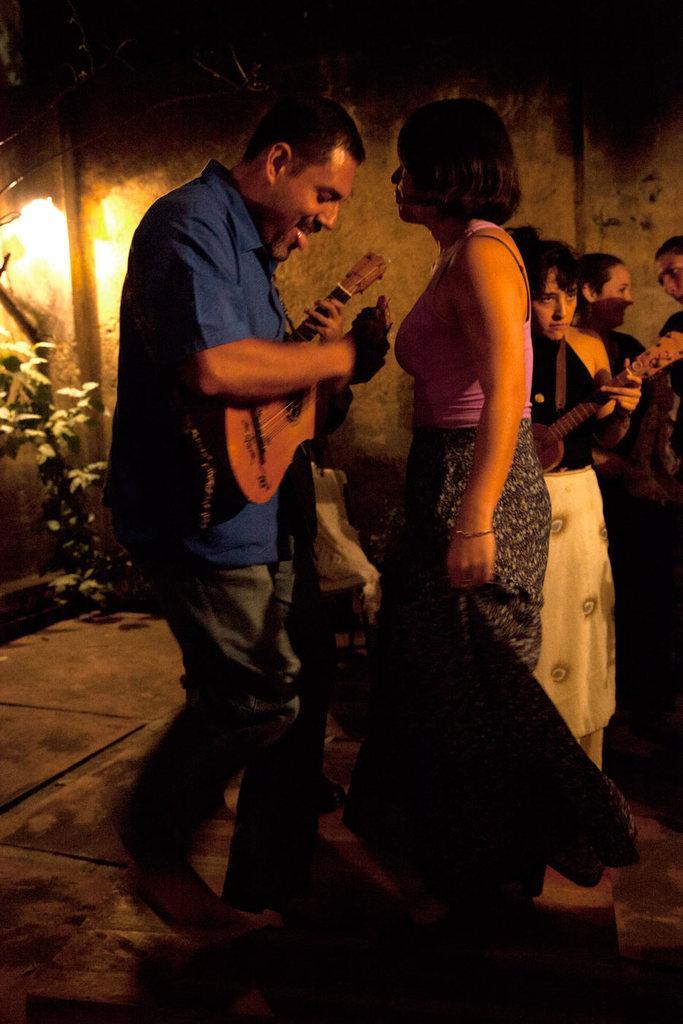How would you summarize this image in a sentence or two? In this image person wearing a blue shirt is holding a guitar. Before there is a woman is standing. At the right side there are few women. In which one woman wearing a black top and white bottom is holding a guitar. At the left side there is a plant and above there is a light. 